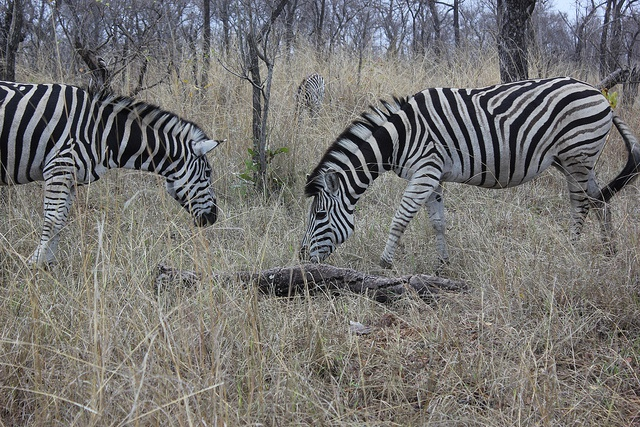Describe the objects in this image and their specific colors. I can see zebra in darkgray, black, and gray tones, zebra in darkgray, black, and gray tones, and zebra in darkgray, gray, and black tones in this image. 